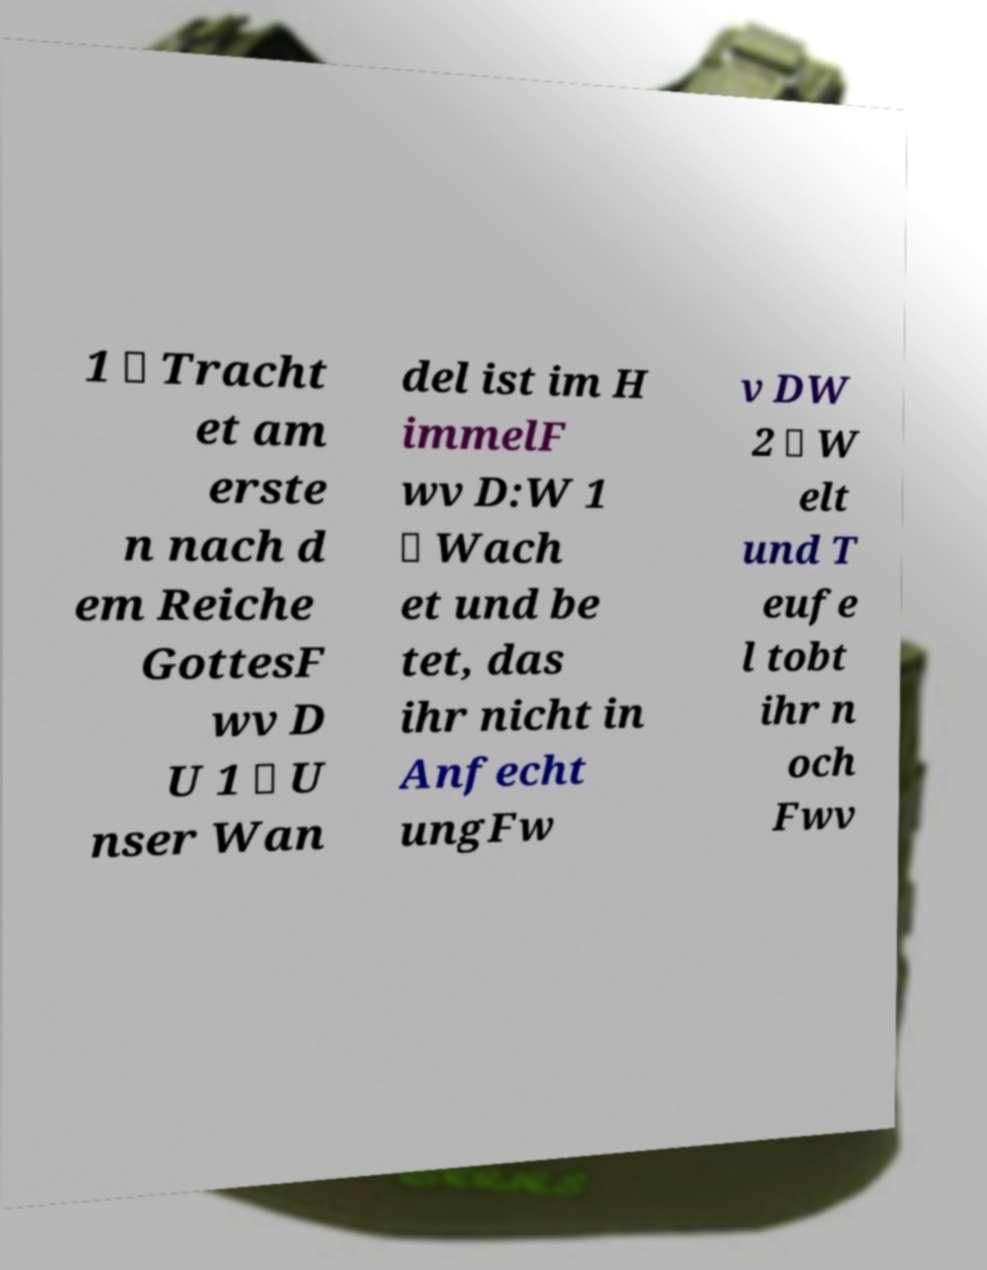Can you read and provide the text displayed in the image?This photo seems to have some interesting text. Can you extract and type it out for me? 1 \ Tracht et am erste n nach d em Reiche GottesF wv D U 1 \ U nser Wan del ist im H immelF wv D:W 1 \ Wach et und be tet, das ihr nicht in Anfecht ungFw v DW 2 \ W elt und T eufe l tobt ihr n och Fwv 